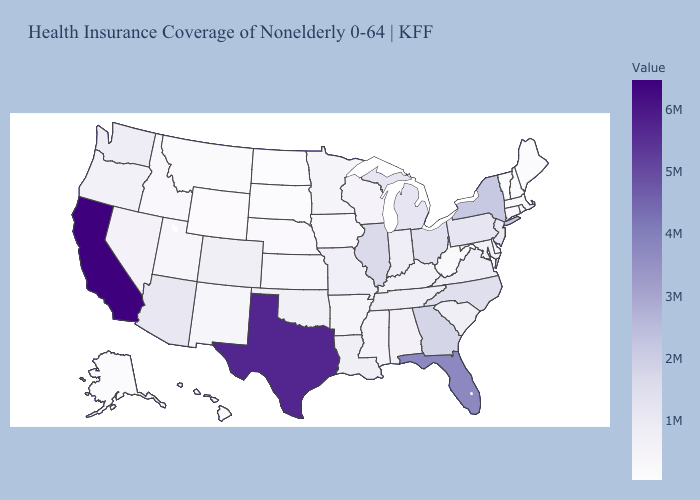Which states hav the highest value in the Northeast?
Concise answer only. New York. Among the states that border Mississippi , which have the highest value?
Write a very short answer. Tennessee. Which states have the lowest value in the USA?
Short answer required. Vermont. Does the map have missing data?
Short answer required. No. Is the legend a continuous bar?
Concise answer only. Yes. Among the states that border Kentucky , does Ohio have the highest value?
Give a very brief answer. No. Which states have the lowest value in the USA?
Write a very short answer. Vermont. 